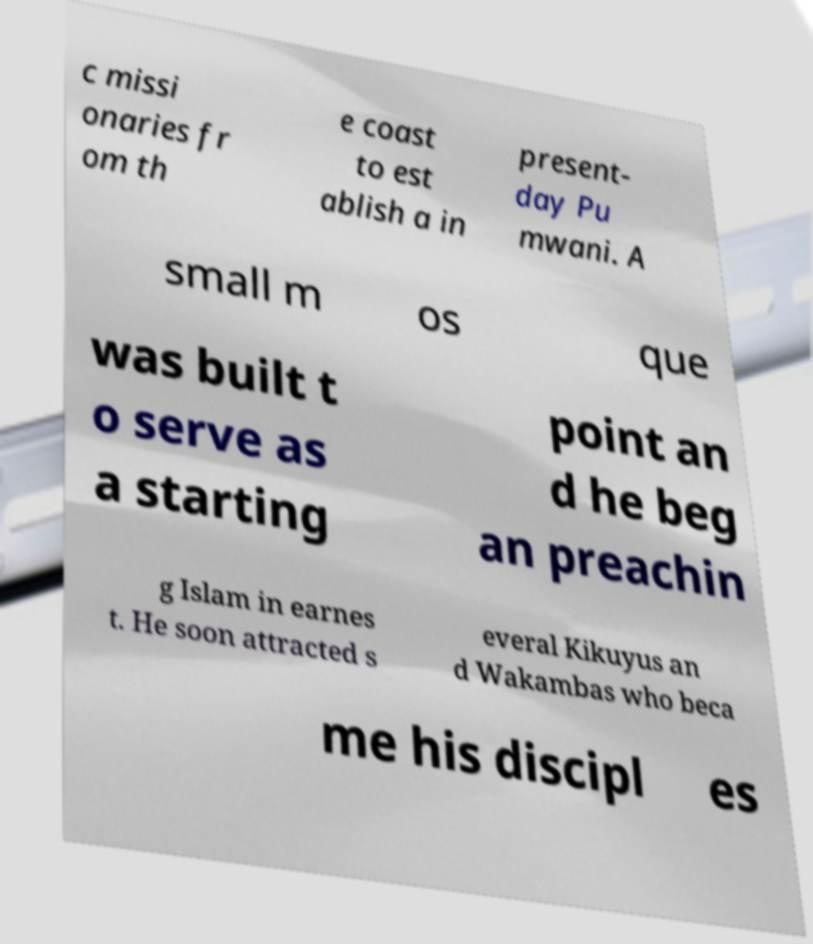Please read and relay the text visible in this image. What does it say? c missi onaries fr om th e coast to est ablish a in present- day Pu mwani. A small m os que was built t o serve as a starting point an d he beg an preachin g Islam in earnes t. He soon attracted s everal Kikuyus an d Wakambas who beca me his discipl es 